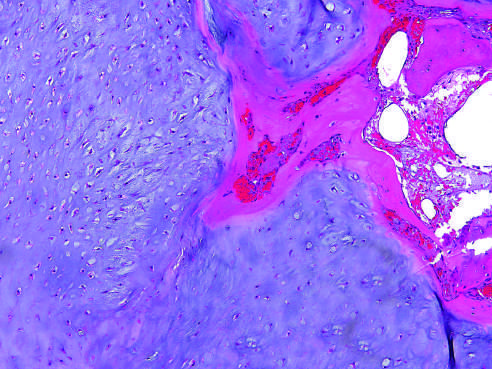how is enchondroma composed?
Answer the question using a single word or phrase. Of a nodule of hyaline cartilage 